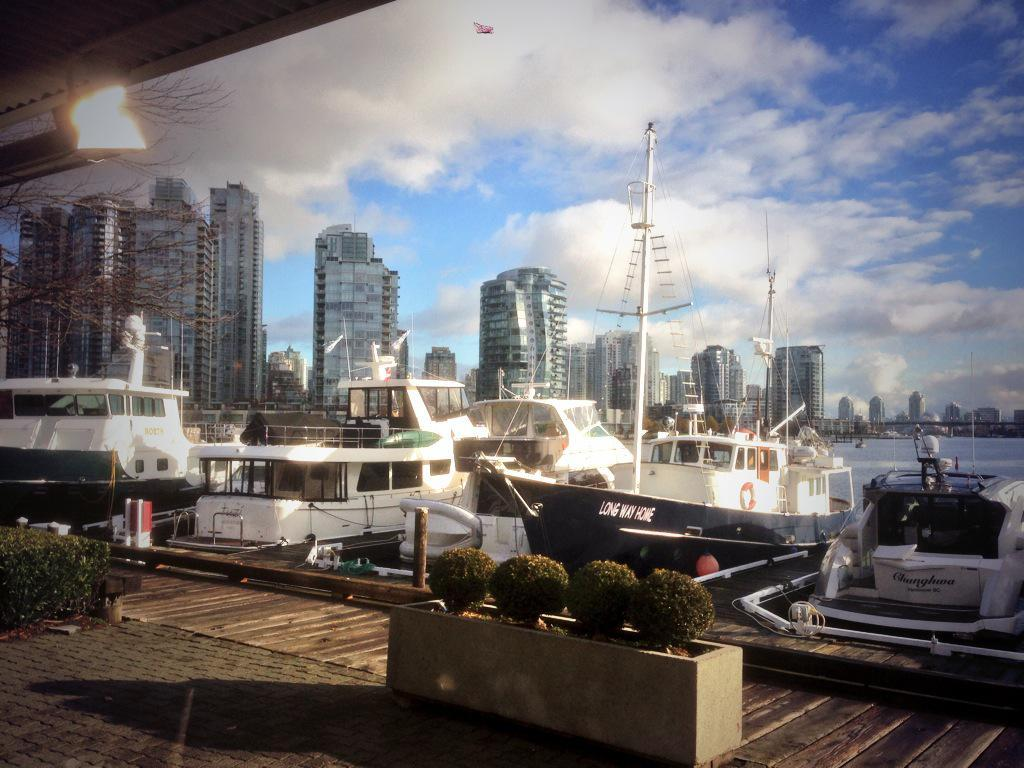What can be seen in the foreground of the image? There are boats and ships in the foreground of the image. What is visible in the background of the image? There are buildings and trees in the background of the image. What type of natural feature is present in the image? There is water visible in the image. How would you describe the weather in the image? The sky is sunny in the background of the image, suggesting a clear and sunny day. How many cats are sitting on the boats in the image? There are no cats present in the image; it features boats and ships in the foreground. 